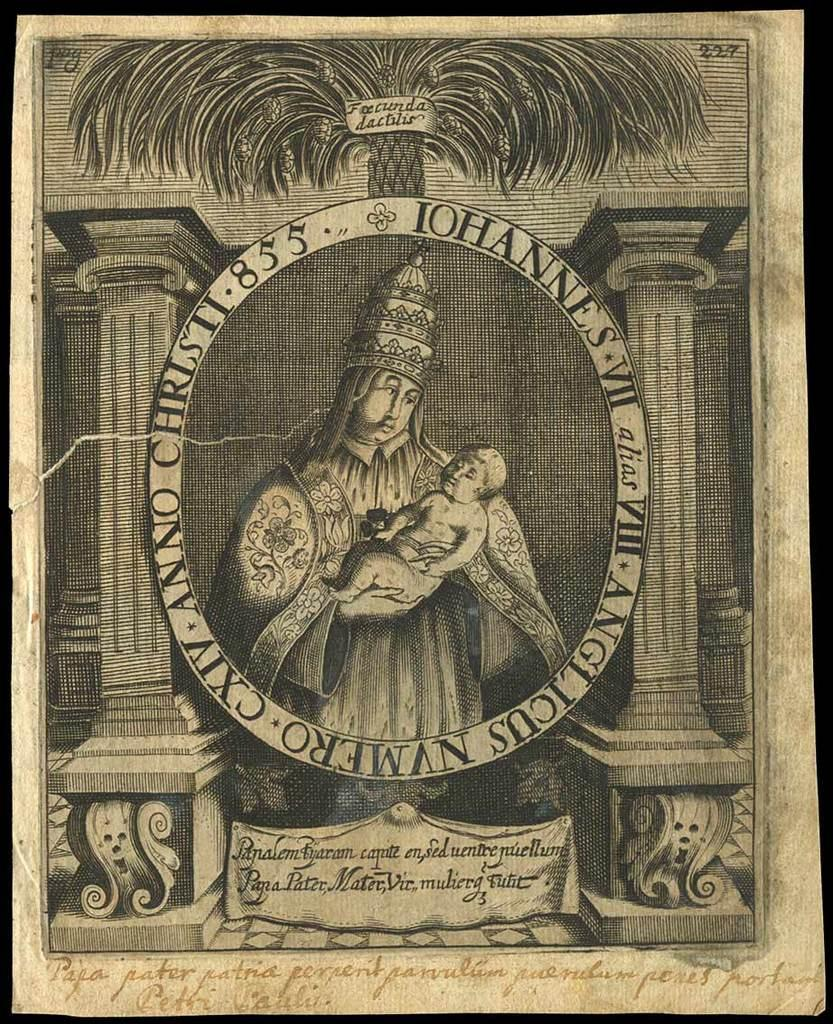What can be found in the image that contains written information? There is text in the image. What activity is the person in the image engaged in? The person is holding a baby in the image. What type of plant is visible in the image? There is a tree in the image. What architectural feature can be seen in the image? There are pillars in the image. What type of insect is crawling on the pillars in the image? There are no insects visible in the image; it only features text, a person holding a baby, a tree, and pillars. What is the title of the book the person is reading to the baby in the image? There is no book or reading activity depicted in the image. 